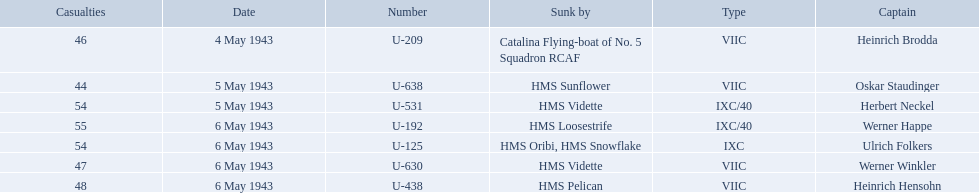Which were the names of the sinkers of the convoys? Catalina Flying-boat of No. 5 Squadron RCAF, HMS Sunflower, HMS Vidette, HMS Loosestrife, HMS Oribi, HMS Snowflake, HMS Vidette, HMS Pelican. What captain was sunk by the hms pelican? Heinrich Hensohn. 